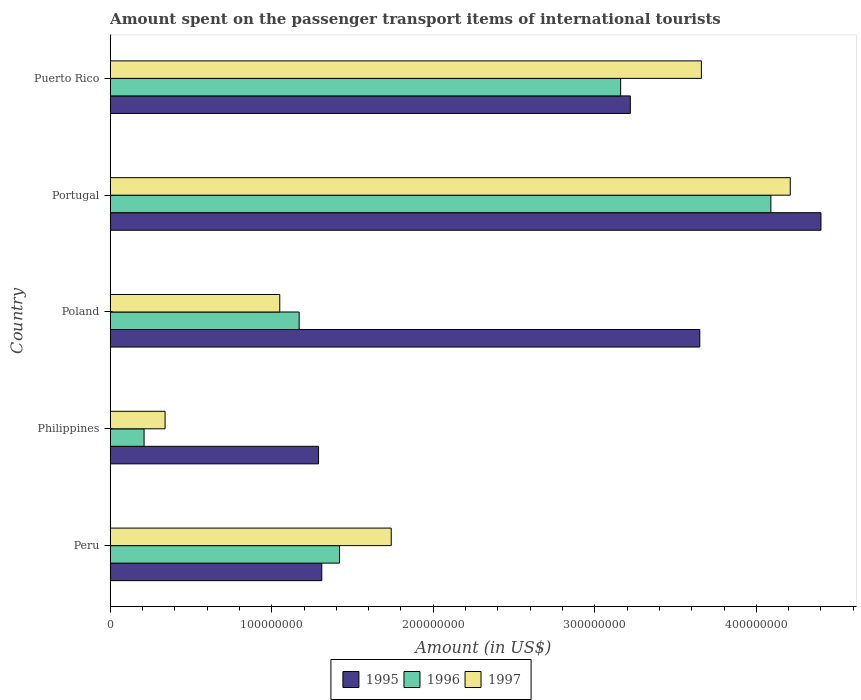Are the number of bars per tick equal to the number of legend labels?
Ensure brevity in your answer.  Yes. Are the number of bars on each tick of the Y-axis equal?
Your answer should be compact. Yes. How many bars are there on the 2nd tick from the top?
Provide a succinct answer. 3. How many bars are there on the 3rd tick from the bottom?
Give a very brief answer. 3. In how many cases, is the number of bars for a given country not equal to the number of legend labels?
Your answer should be compact. 0. What is the amount spent on the passenger transport items of international tourists in 1996 in Peru?
Your answer should be very brief. 1.42e+08. Across all countries, what is the maximum amount spent on the passenger transport items of international tourists in 1997?
Your answer should be very brief. 4.21e+08. Across all countries, what is the minimum amount spent on the passenger transport items of international tourists in 1995?
Provide a short and direct response. 1.29e+08. In which country was the amount spent on the passenger transport items of international tourists in 1995 maximum?
Your answer should be compact. Portugal. In which country was the amount spent on the passenger transport items of international tourists in 1995 minimum?
Your response must be concise. Philippines. What is the total amount spent on the passenger transport items of international tourists in 1996 in the graph?
Provide a short and direct response. 1.00e+09. What is the difference between the amount spent on the passenger transport items of international tourists in 1995 in Philippines and that in Puerto Rico?
Provide a short and direct response. -1.93e+08. What is the difference between the amount spent on the passenger transport items of international tourists in 1996 in Philippines and the amount spent on the passenger transport items of international tourists in 1997 in Puerto Rico?
Offer a terse response. -3.45e+08. What is the average amount spent on the passenger transport items of international tourists in 1996 per country?
Your answer should be very brief. 2.01e+08. What is the difference between the amount spent on the passenger transport items of international tourists in 1996 and amount spent on the passenger transport items of international tourists in 1997 in Philippines?
Give a very brief answer. -1.30e+07. In how many countries, is the amount spent on the passenger transport items of international tourists in 1996 greater than 420000000 US$?
Offer a very short reply. 0. What is the ratio of the amount spent on the passenger transport items of international tourists in 1995 in Philippines to that in Puerto Rico?
Give a very brief answer. 0.4. Is the amount spent on the passenger transport items of international tourists in 1996 in Poland less than that in Puerto Rico?
Provide a short and direct response. Yes. What is the difference between the highest and the second highest amount spent on the passenger transport items of international tourists in 1996?
Provide a succinct answer. 9.30e+07. What is the difference between the highest and the lowest amount spent on the passenger transport items of international tourists in 1995?
Offer a terse response. 3.11e+08. Is the sum of the amount spent on the passenger transport items of international tourists in 1997 in Portugal and Puerto Rico greater than the maximum amount spent on the passenger transport items of international tourists in 1995 across all countries?
Keep it short and to the point. Yes. What does the 3rd bar from the top in Poland represents?
Your response must be concise. 1995. How many countries are there in the graph?
Your answer should be compact. 5. What is the difference between two consecutive major ticks on the X-axis?
Provide a succinct answer. 1.00e+08. Are the values on the major ticks of X-axis written in scientific E-notation?
Offer a terse response. No. Does the graph contain grids?
Your response must be concise. No. How many legend labels are there?
Offer a very short reply. 3. How are the legend labels stacked?
Give a very brief answer. Horizontal. What is the title of the graph?
Offer a terse response. Amount spent on the passenger transport items of international tourists. Does "2005" appear as one of the legend labels in the graph?
Provide a succinct answer. No. What is the Amount (in US$) in 1995 in Peru?
Provide a succinct answer. 1.31e+08. What is the Amount (in US$) in 1996 in Peru?
Offer a very short reply. 1.42e+08. What is the Amount (in US$) in 1997 in Peru?
Give a very brief answer. 1.74e+08. What is the Amount (in US$) in 1995 in Philippines?
Provide a succinct answer. 1.29e+08. What is the Amount (in US$) in 1996 in Philippines?
Keep it short and to the point. 2.10e+07. What is the Amount (in US$) in 1997 in Philippines?
Give a very brief answer. 3.40e+07. What is the Amount (in US$) in 1995 in Poland?
Give a very brief answer. 3.65e+08. What is the Amount (in US$) in 1996 in Poland?
Make the answer very short. 1.17e+08. What is the Amount (in US$) of 1997 in Poland?
Provide a short and direct response. 1.05e+08. What is the Amount (in US$) in 1995 in Portugal?
Ensure brevity in your answer.  4.40e+08. What is the Amount (in US$) of 1996 in Portugal?
Ensure brevity in your answer.  4.09e+08. What is the Amount (in US$) of 1997 in Portugal?
Make the answer very short. 4.21e+08. What is the Amount (in US$) in 1995 in Puerto Rico?
Give a very brief answer. 3.22e+08. What is the Amount (in US$) of 1996 in Puerto Rico?
Your response must be concise. 3.16e+08. What is the Amount (in US$) of 1997 in Puerto Rico?
Provide a succinct answer. 3.66e+08. Across all countries, what is the maximum Amount (in US$) in 1995?
Ensure brevity in your answer.  4.40e+08. Across all countries, what is the maximum Amount (in US$) of 1996?
Offer a terse response. 4.09e+08. Across all countries, what is the maximum Amount (in US$) of 1997?
Provide a succinct answer. 4.21e+08. Across all countries, what is the minimum Amount (in US$) in 1995?
Your answer should be compact. 1.29e+08. Across all countries, what is the minimum Amount (in US$) of 1996?
Give a very brief answer. 2.10e+07. Across all countries, what is the minimum Amount (in US$) in 1997?
Your answer should be very brief. 3.40e+07. What is the total Amount (in US$) in 1995 in the graph?
Your answer should be very brief. 1.39e+09. What is the total Amount (in US$) in 1996 in the graph?
Ensure brevity in your answer.  1.00e+09. What is the total Amount (in US$) in 1997 in the graph?
Ensure brevity in your answer.  1.10e+09. What is the difference between the Amount (in US$) in 1996 in Peru and that in Philippines?
Keep it short and to the point. 1.21e+08. What is the difference between the Amount (in US$) of 1997 in Peru and that in Philippines?
Keep it short and to the point. 1.40e+08. What is the difference between the Amount (in US$) of 1995 in Peru and that in Poland?
Provide a short and direct response. -2.34e+08. What is the difference between the Amount (in US$) of 1996 in Peru and that in Poland?
Keep it short and to the point. 2.50e+07. What is the difference between the Amount (in US$) in 1997 in Peru and that in Poland?
Ensure brevity in your answer.  6.90e+07. What is the difference between the Amount (in US$) in 1995 in Peru and that in Portugal?
Provide a short and direct response. -3.09e+08. What is the difference between the Amount (in US$) of 1996 in Peru and that in Portugal?
Offer a terse response. -2.67e+08. What is the difference between the Amount (in US$) in 1997 in Peru and that in Portugal?
Provide a succinct answer. -2.47e+08. What is the difference between the Amount (in US$) in 1995 in Peru and that in Puerto Rico?
Ensure brevity in your answer.  -1.91e+08. What is the difference between the Amount (in US$) in 1996 in Peru and that in Puerto Rico?
Keep it short and to the point. -1.74e+08. What is the difference between the Amount (in US$) in 1997 in Peru and that in Puerto Rico?
Give a very brief answer. -1.92e+08. What is the difference between the Amount (in US$) in 1995 in Philippines and that in Poland?
Offer a very short reply. -2.36e+08. What is the difference between the Amount (in US$) in 1996 in Philippines and that in Poland?
Provide a short and direct response. -9.60e+07. What is the difference between the Amount (in US$) of 1997 in Philippines and that in Poland?
Ensure brevity in your answer.  -7.10e+07. What is the difference between the Amount (in US$) in 1995 in Philippines and that in Portugal?
Your answer should be very brief. -3.11e+08. What is the difference between the Amount (in US$) of 1996 in Philippines and that in Portugal?
Provide a succinct answer. -3.88e+08. What is the difference between the Amount (in US$) of 1997 in Philippines and that in Portugal?
Provide a succinct answer. -3.87e+08. What is the difference between the Amount (in US$) in 1995 in Philippines and that in Puerto Rico?
Your answer should be very brief. -1.93e+08. What is the difference between the Amount (in US$) of 1996 in Philippines and that in Puerto Rico?
Offer a terse response. -2.95e+08. What is the difference between the Amount (in US$) in 1997 in Philippines and that in Puerto Rico?
Your answer should be compact. -3.32e+08. What is the difference between the Amount (in US$) of 1995 in Poland and that in Portugal?
Keep it short and to the point. -7.50e+07. What is the difference between the Amount (in US$) in 1996 in Poland and that in Portugal?
Offer a terse response. -2.92e+08. What is the difference between the Amount (in US$) in 1997 in Poland and that in Portugal?
Your answer should be very brief. -3.16e+08. What is the difference between the Amount (in US$) in 1995 in Poland and that in Puerto Rico?
Give a very brief answer. 4.30e+07. What is the difference between the Amount (in US$) in 1996 in Poland and that in Puerto Rico?
Give a very brief answer. -1.99e+08. What is the difference between the Amount (in US$) of 1997 in Poland and that in Puerto Rico?
Your answer should be very brief. -2.61e+08. What is the difference between the Amount (in US$) of 1995 in Portugal and that in Puerto Rico?
Make the answer very short. 1.18e+08. What is the difference between the Amount (in US$) in 1996 in Portugal and that in Puerto Rico?
Ensure brevity in your answer.  9.30e+07. What is the difference between the Amount (in US$) in 1997 in Portugal and that in Puerto Rico?
Your answer should be compact. 5.50e+07. What is the difference between the Amount (in US$) in 1995 in Peru and the Amount (in US$) in 1996 in Philippines?
Offer a very short reply. 1.10e+08. What is the difference between the Amount (in US$) in 1995 in Peru and the Amount (in US$) in 1997 in Philippines?
Give a very brief answer. 9.70e+07. What is the difference between the Amount (in US$) in 1996 in Peru and the Amount (in US$) in 1997 in Philippines?
Provide a succinct answer. 1.08e+08. What is the difference between the Amount (in US$) of 1995 in Peru and the Amount (in US$) of 1996 in Poland?
Your answer should be very brief. 1.40e+07. What is the difference between the Amount (in US$) in 1995 in Peru and the Amount (in US$) in 1997 in Poland?
Offer a terse response. 2.60e+07. What is the difference between the Amount (in US$) of 1996 in Peru and the Amount (in US$) of 1997 in Poland?
Your answer should be compact. 3.70e+07. What is the difference between the Amount (in US$) in 1995 in Peru and the Amount (in US$) in 1996 in Portugal?
Offer a terse response. -2.78e+08. What is the difference between the Amount (in US$) of 1995 in Peru and the Amount (in US$) of 1997 in Portugal?
Provide a short and direct response. -2.90e+08. What is the difference between the Amount (in US$) in 1996 in Peru and the Amount (in US$) in 1997 in Portugal?
Provide a short and direct response. -2.79e+08. What is the difference between the Amount (in US$) in 1995 in Peru and the Amount (in US$) in 1996 in Puerto Rico?
Offer a very short reply. -1.85e+08. What is the difference between the Amount (in US$) of 1995 in Peru and the Amount (in US$) of 1997 in Puerto Rico?
Make the answer very short. -2.35e+08. What is the difference between the Amount (in US$) in 1996 in Peru and the Amount (in US$) in 1997 in Puerto Rico?
Offer a terse response. -2.24e+08. What is the difference between the Amount (in US$) in 1995 in Philippines and the Amount (in US$) in 1997 in Poland?
Make the answer very short. 2.40e+07. What is the difference between the Amount (in US$) of 1996 in Philippines and the Amount (in US$) of 1997 in Poland?
Give a very brief answer. -8.40e+07. What is the difference between the Amount (in US$) in 1995 in Philippines and the Amount (in US$) in 1996 in Portugal?
Provide a short and direct response. -2.80e+08. What is the difference between the Amount (in US$) in 1995 in Philippines and the Amount (in US$) in 1997 in Portugal?
Provide a short and direct response. -2.92e+08. What is the difference between the Amount (in US$) in 1996 in Philippines and the Amount (in US$) in 1997 in Portugal?
Your response must be concise. -4.00e+08. What is the difference between the Amount (in US$) in 1995 in Philippines and the Amount (in US$) in 1996 in Puerto Rico?
Your response must be concise. -1.87e+08. What is the difference between the Amount (in US$) of 1995 in Philippines and the Amount (in US$) of 1997 in Puerto Rico?
Offer a terse response. -2.37e+08. What is the difference between the Amount (in US$) in 1996 in Philippines and the Amount (in US$) in 1997 in Puerto Rico?
Keep it short and to the point. -3.45e+08. What is the difference between the Amount (in US$) of 1995 in Poland and the Amount (in US$) of 1996 in Portugal?
Provide a short and direct response. -4.40e+07. What is the difference between the Amount (in US$) of 1995 in Poland and the Amount (in US$) of 1997 in Portugal?
Give a very brief answer. -5.60e+07. What is the difference between the Amount (in US$) in 1996 in Poland and the Amount (in US$) in 1997 in Portugal?
Offer a terse response. -3.04e+08. What is the difference between the Amount (in US$) in 1995 in Poland and the Amount (in US$) in 1996 in Puerto Rico?
Offer a very short reply. 4.90e+07. What is the difference between the Amount (in US$) in 1995 in Poland and the Amount (in US$) in 1997 in Puerto Rico?
Your answer should be very brief. -1.00e+06. What is the difference between the Amount (in US$) in 1996 in Poland and the Amount (in US$) in 1997 in Puerto Rico?
Keep it short and to the point. -2.49e+08. What is the difference between the Amount (in US$) of 1995 in Portugal and the Amount (in US$) of 1996 in Puerto Rico?
Give a very brief answer. 1.24e+08. What is the difference between the Amount (in US$) in 1995 in Portugal and the Amount (in US$) in 1997 in Puerto Rico?
Provide a succinct answer. 7.40e+07. What is the difference between the Amount (in US$) of 1996 in Portugal and the Amount (in US$) of 1997 in Puerto Rico?
Keep it short and to the point. 4.30e+07. What is the average Amount (in US$) in 1995 per country?
Give a very brief answer. 2.77e+08. What is the average Amount (in US$) of 1996 per country?
Give a very brief answer. 2.01e+08. What is the average Amount (in US$) of 1997 per country?
Provide a succinct answer. 2.20e+08. What is the difference between the Amount (in US$) in 1995 and Amount (in US$) in 1996 in Peru?
Your answer should be compact. -1.10e+07. What is the difference between the Amount (in US$) of 1995 and Amount (in US$) of 1997 in Peru?
Your response must be concise. -4.30e+07. What is the difference between the Amount (in US$) of 1996 and Amount (in US$) of 1997 in Peru?
Your response must be concise. -3.20e+07. What is the difference between the Amount (in US$) of 1995 and Amount (in US$) of 1996 in Philippines?
Give a very brief answer. 1.08e+08. What is the difference between the Amount (in US$) of 1995 and Amount (in US$) of 1997 in Philippines?
Provide a short and direct response. 9.50e+07. What is the difference between the Amount (in US$) in 1996 and Amount (in US$) in 1997 in Philippines?
Provide a short and direct response. -1.30e+07. What is the difference between the Amount (in US$) of 1995 and Amount (in US$) of 1996 in Poland?
Your answer should be very brief. 2.48e+08. What is the difference between the Amount (in US$) in 1995 and Amount (in US$) in 1997 in Poland?
Ensure brevity in your answer.  2.60e+08. What is the difference between the Amount (in US$) in 1996 and Amount (in US$) in 1997 in Poland?
Make the answer very short. 1.20e+07. What is the difference between the Amount (in US$) in 1995 and Amount (in US$) in 1996 in Portugal?
Your answer should be very brief. 3.10e+07. What is the difference between the Amount (in US$) of 1995 and Amount (in US$) of 1997 in Portugal?
Keep it short and to the point. 1.90e+07. What is the difference between the Amount (in US$) in 1996 and Amount (in US$) in 1997 in Portugal?
Offer a very short reply. -1.20e+07. What is the difference between the Amount (in US$) of 1995 and Amount (in US$) of 1997 in Puerto Rico?
Offer a terse response. -4.40e+07. What is the difference between the Amount (in US$) in 1996 and Amount (in US$) in 1997 in Puerto Rico?
Keep it short and to the point. -5.00e+07. What is the ratio of the Amount (in US$) in 1995 in Peru to that in Philippines?
Offer a terse response. 1.02. What is the ratio of the Amount (in US$) of 1996 in Peru to that in Philippines?
Offer a very short reply. 6.76. What is the ratio of the Amount (in US$) of 1997 in Peru to that in Philippines?
Keep it short and to the point. 5.12. What is the ratio of the Amount (in US$) in 1995 in Peru to that in Poland?
Offer a very short reply. 0.36. What is the ratio of the Amount (in US$) in 1996 in Peru to that in Poland?
Offer a very short reply. 1.21. What is the ratio of the Amount (in US$) of 1997 in Peru to that in Poland?
Provide a succinct answer. 1.66. What is the ratio of the Amount (in US$) of 1995 in Peru to that in Portugal?
Offer a terse response. 0.3. What is the ratio of the Amount (in US$) of 1996 in Peru to that in Portugal?
Your answer should be very brief. 0.35. What is the ratio of the Amount (in US$) of 1997 in Peru to that in Portugal?
Offer a terse response. 0.41. What is the ratio of the Amount (in US$) in 1995 in Peru to that in Puerto Rico?
Keep it short and to the point. 0.41. What is the ratio of the Amount (in US$) in 1996 in Peru to that in Puerto Rico?
Provide a short and direct response. 0.45. What is the ratio of the Amount (in US$) in 1997 in Peru to that in Puerto Rico?
Offer a very short reply. 0.48. What is the ratio of the Amount (in US$) in 1995 in Philippines to that in Poland?
Provide a succinct answer. 0.35. What is the ratio of the Amount (in US$) of 1996 in Philippines to that in Poland?
Ensure brevity in your answer.  0.18. What is the ratio of the Amount (in US$) of 1997 in Philippines to that in Poland?
Provide a short and direct response. 0.32. What is the ratio of the Amount (in US$) in 1995 in Philippines to that in Portugal?
Provide a succinct answer. 0.29. What is the ratio of the Amount (in US$) in 1996 in Philippines to that in Portugal?
Provide a succinct answer. 0.05. What is the ratio of the Amount (in US$) in 1997 in Philippines to that in Portugal?
Make the answer very short. 0.08. What is the ratio of the Amount (in US$) in 1995 in Philippines to that in Puerto Rico?
Keep it short and to the point. 0.4. What is the ratio of the Amount (in US$) in 1996 in Philippines to that in Puerto Rico?
Make the answer very short. 0.07. What is the ratio of the Amount (in US$) in 1997 in Philippines to that in Puerto Rico?
Provide a short and direct response. 0.09. What is the ratio of the Amount (in US$) in 1995 in Poland to that in Portugal?
Ensure brevity in your answer.  0.83. What is the ratio of the Amount (in US$) of 1996 in Poland to that in Portugal?
Your answer should be compact. 0.29. What is the ratio of the Amount (in US$) of 1997 in Poland to that in Portugal?
Your answer should be very brief. 0.25. What is the ratio of the Amount (in US$) in 1995 in Poland to that in Puerto Rico?
Provide a succinct answer. 1.13. What is the ratio of the Amount (in US$) in 1996 in Poland to that in Puerto Rico?
Your answer should be very brief. 0.37. What is the ratio of the Amount (in US$) of 1997 in Poland to that in Puerto Rico?
Your answer should be very brief. 0.29. What is the ratio of the Amount (in US$) in 1995 in Portugal to that in Puerto Rico?
Keep it short and to the point. 1.37. What is the ratio of the Amount (in US$) of 1996 in Portugal to that in Puerto Rico?
Give a very brief answer. 1.29. What is the ratio of the Amount (in US$) of 1997 in Portugal to that in Puerto Rico?
Provide a short and direct response. 1.15. What is the difference between the highest and the second highest Amount (in US$) of 1995?
Make the answer very short. 7.50e+07. What is the difference between the highest and the second highest Amount (in US$) in 1996?
Provide a short and direct response. 9.30e+07. What is the difference between the highest and the second highest Amount (in US$) of 1997?
Make the answer very short. 5.50e+07. What is the difference between the highest and the lowest Amount (in US$) in 1995?
Offer a very short reply. 3.11e+08. What is the difference between the highest and the lowest Amount (in US$) of 1996?
Ensure brevity in your answer.  3.88e+08. What is the difference between the highest and the lowest Amount (in US$) of 1997?
Your answer should be compact. 3.87e+08. 